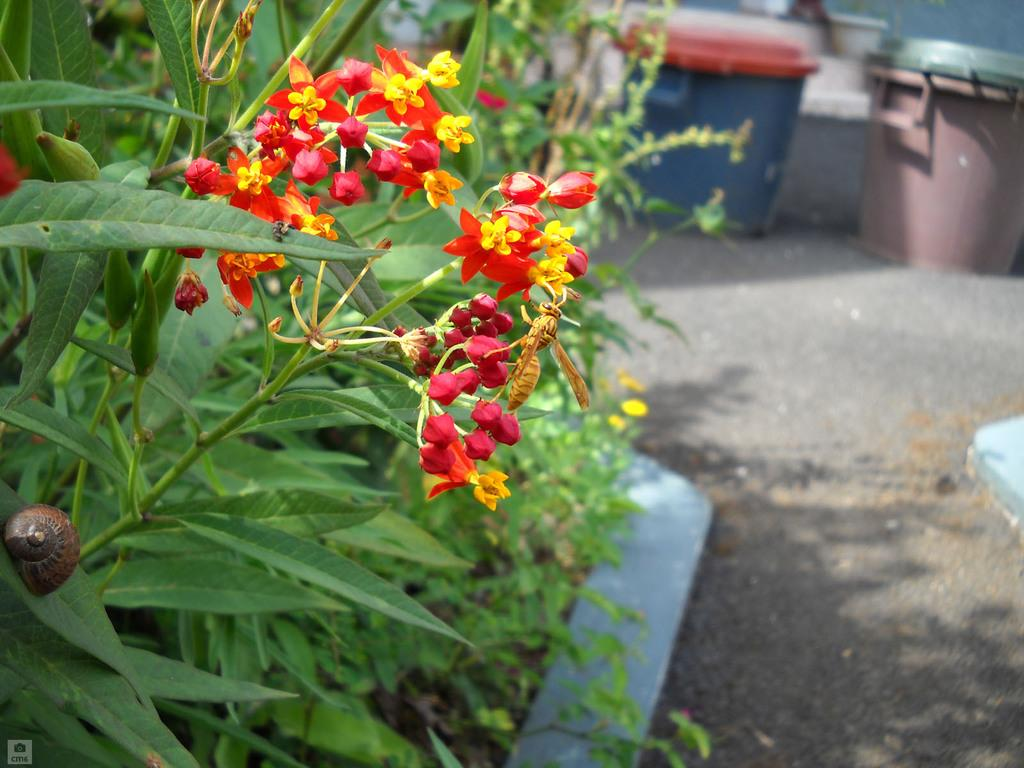What type of vegetation can be seen on the right side of the image? There are plants on the right side of the image. What specific part of the plants is visible in the image? Flowers are visible in the image. What type of containers can be seen in the background of the image? There are bins in the background of the image. What is visible at the bottom of the image? The ground is visible at the bottom of the image. Can you see a foot resting on the ground in the image? There is no foot or person visible in the image; it only features plants, flowers, bins, and the ground. What type of clothing is hanging on the plants in the image? There is no clothing or vest present in the image; it only features plants, flowers, bins, and the ground. 